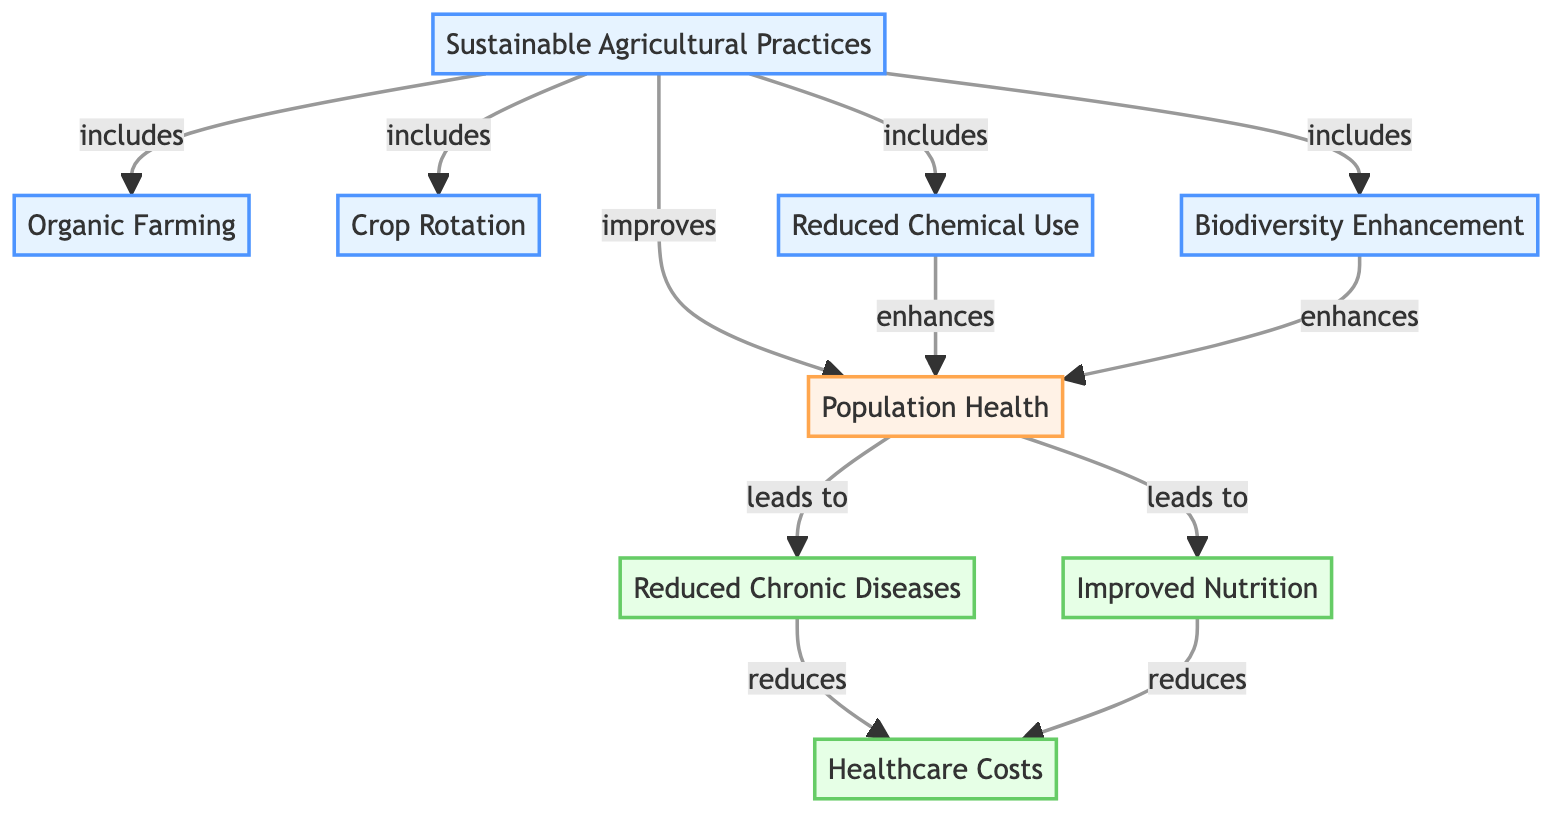What are the sustainable agricultural practices included in the diagram? The diagram lists four sustainable agricultural practices: Organic Farming, Crop Rotation, Reduced Chemical Use, and Biodiversity Enhancement. Each of these is directly connected as components of Sustainable Agricultural Practices.
Answer: Organic Farming, Crop Rotation, Reduced Chemical Use, Biodiversity Enhancement How many sustainable practices are depicted in the diagram? By counting the nodes connected to the Sustainable Agricultural Practices node, there are four distinct practices, which include Organic Farming, Crop Rotation, Reduced Chemical Use, and Biodiversity Enhancement.
Answer: 4 What is the effect of Reduced Chemical Use on population health? The diagram shows that Reduced Chemical Use enhances population health. This indicates a direct positive impact from the practice to the health outcome.
Answer: enhances Which outcomes are linked to improved nutrition? According to the diagram, improved nutrition leads to a reduction in healthcare costs. This is the only outcome that is directly linked to it.
Answer: reduces healthcare costs How does biodiversity influence population health? The flowchart indicates that Biodiversity Enhancement directly enhances population health, implying that a diverse ecosystem positively affects the health of the population.
Answer: enhances What is the final outcome derived from reduced chronic diseases? The diagram illustrates that Reduced Chronic Diseases leads to a reduction in healthcare costs, indicating its positive economic impact on health expenditures.
Answer: reduces healthcare costs What is the relationship between population health and healthcare costs? The diagram shows that improved population health leads to reduced healthcare costs, which establishes a clear link between the two aspects.
Answer: leads to reduced healthcare costs Which sustainable practice does not lead to an outcome directly associated with healthcare costs? The diagram shows that both Organic Farming and Crop Rotation are sustainable practices. However, only Reduced Chemical Use and Biodiversity Enhancement are directly linked to improving population health and impacting healthcare costs; thus, Organic Farming and Crop Rotation do not have a direct impact on healthcare costs.
Answer: Organic Farming, Crop Rotation 